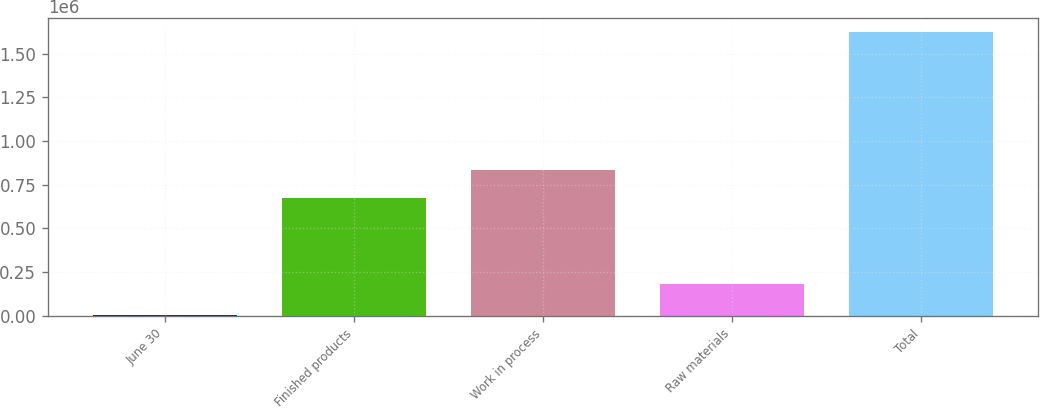Convert chart to OTSL. <chart><loc_0><loc_0><loc_500><loc_500><bar_chart><fcel>June 30<fcel>Finished products<fcel>Work in process<fcel>Raw materials<fcel>Total<nl><fcel>2018<fcel>673323<fcel>835252<fcel>182146<fcel>1.6213e+06<nl></chart> 